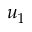<formula> <loc_0><loc_0><loc_500><loc_500>u _ { 1 }</formula> 